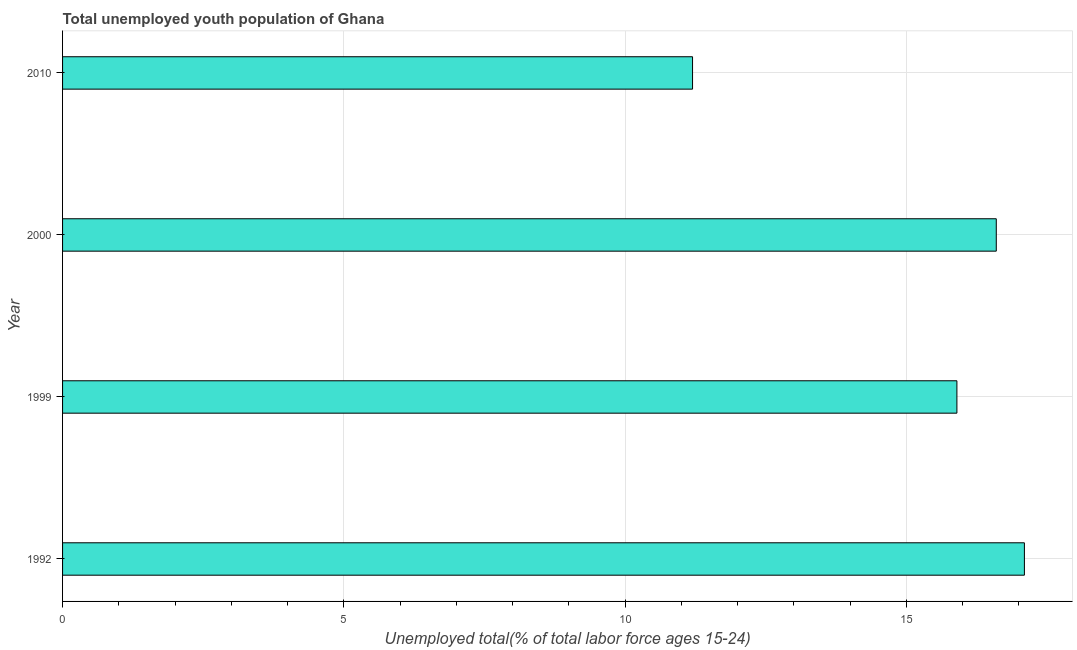Does the graph contain any zero values?
Offer a very short reply. No. Does the graph contain grids?
Provide a succinct answer. Yes. What is the title of the graph?
Provide a succinct answer. Total unemployed youth population of Ghana. What is the label or title of the X-axis?
Your answer should be very brief. Unemployed total(% of total labor force ages 15-24). What is the unemployed youth in 2010?
Provide a succinct answer. 11.2. Across all years, what is the maximum unemployed youth?
Your answer should be very brief. 17.1. Across all years, what is the minimum unemployed youth?
Offer a terse response. 11.2. What is the sum of the unemployed youth?
Provide a succinct answer. 60.8. What is the median unemployed youth?
Your response must be concise. 16.25. In how many years, is the unemployed youth greater than 3 %?
Give a very brief answer. 4. What is the ratio of the unemployed youth in 2000 to that in 2010?
Give a very brief answer. 1.48. Is the unemployed youth in 1992 less than that in 1999?
Your response must be concise. No. What is the difference between the highest and the second highest unemployed youth?
Keep it short and to the point. 0.5. How many bars are there?
Offer a terse response. 4. How many years are there in the graph?
Make the answer very short. 4. What is the difference between two consecutive major ticks on the X-axis?
Your response must be concise. 5. Are the values on the major ticks of X-axis written in scientific E-notation?
Give a very brief answer. No. What is the Unemployed total(% of total labor force ages 15-24) in 1992?
Give a very brief answer. 17.1. What is the Unemployed total(% of total labor force ages 15-24) in 1999?
Give a very brief answer. 15.9. What is the Unemployed total(% of total labor force ages 15-24) of 2000?
Your response must be concise. 16.6. What is the Unemployed total(% of total labor force ages 15-24) in 2010?
Your answer should be very brief. 11.2. What is the ratio of the Unemployed total(% of total labor force ages 15-24) in 1992 to that in 1999?
Ensure brevity in your answer.  1.07. What is the ratio of the Unemployed total(% of total labor force ages 15-24) in 1992 to that in 2010?
Provide a short and direct response. 1.53. What is the ratio of the Unemployed total(% of total labor force ages 15-24) in 1999 to that in 2000?
Your answer should be compact. 0.96. What is the ratio of the Unemployed total(% of total labor force ages 15-24) in 1999 to that in 2010?
Keep it short and to the point. 1.42. What is the ratio of the Unemployed total(% of total labor force ages 15-24) in 2000 to that in 2010?
Your response must be concise. 1.48. 